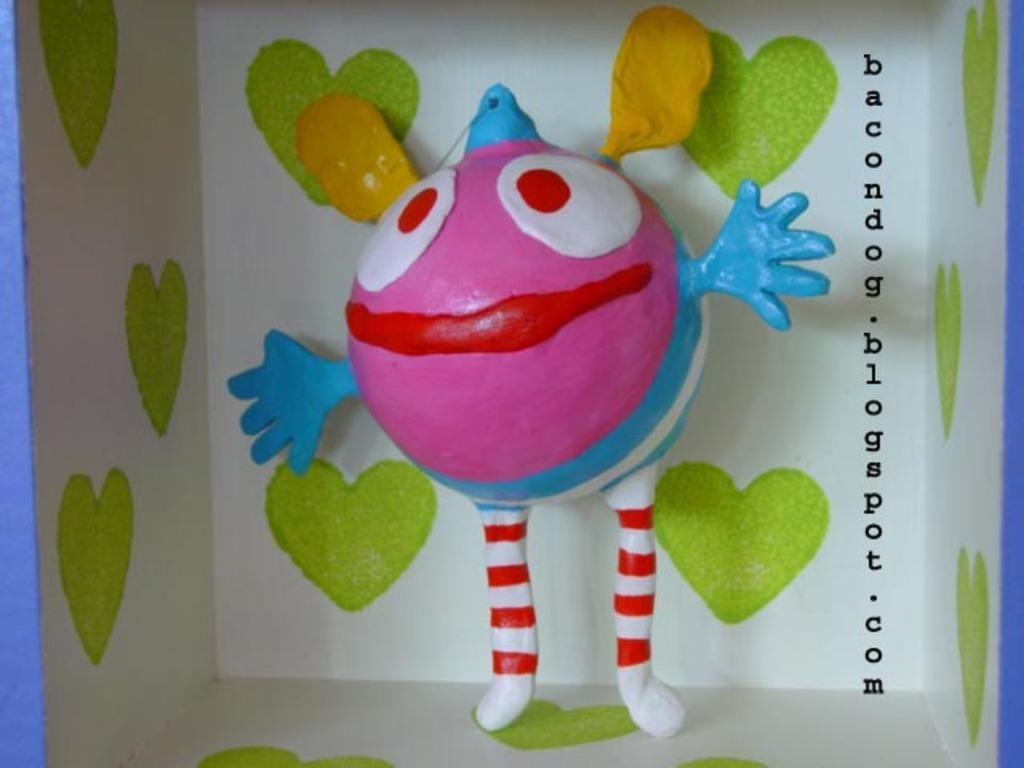In one or two sentences, can you explain what this image depicts? In the middle of the image there is a toy with pink, white, red, blue and green colors on it. In the background and to the sides there is a white background with green color heart symbols on it. And to the right side of the image there is an email address. 